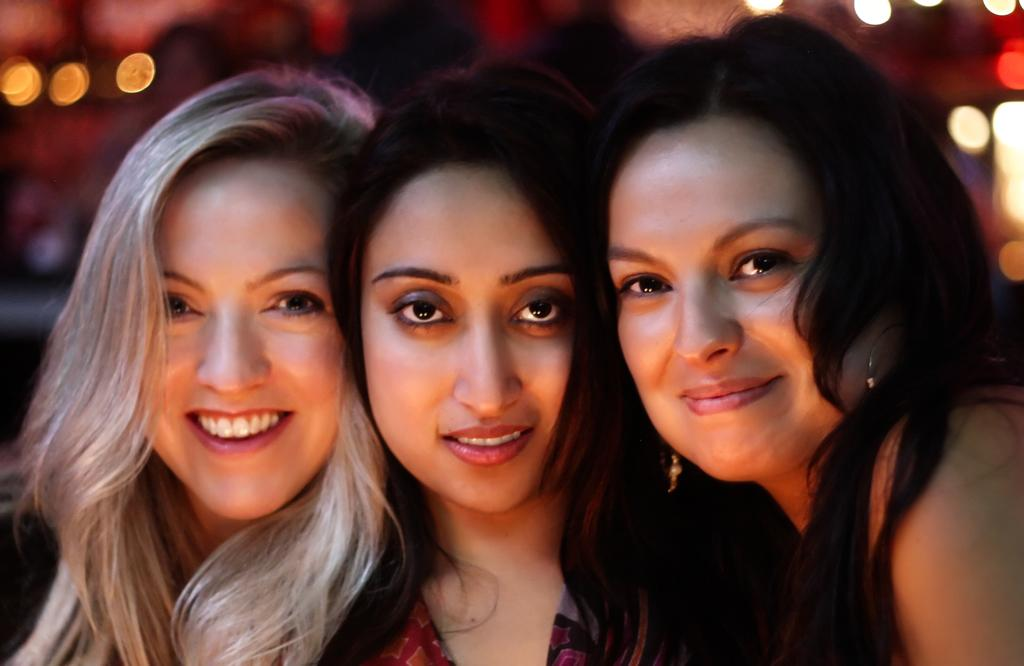How many people are in the image? There are three women in the image. What is the facial expression of the women? The women are smiling in the image. What are the women doing in the image? The women are posing for the picture. What can be seen in the background of the image? There are lights in the background of the image. How would you describe the background's appearance? The background is blurred. How many brothers do the women have in the image? There is no information about the women's brothers in the image. What fact can be learned about the coach in the image? There is no coach present in the image. 